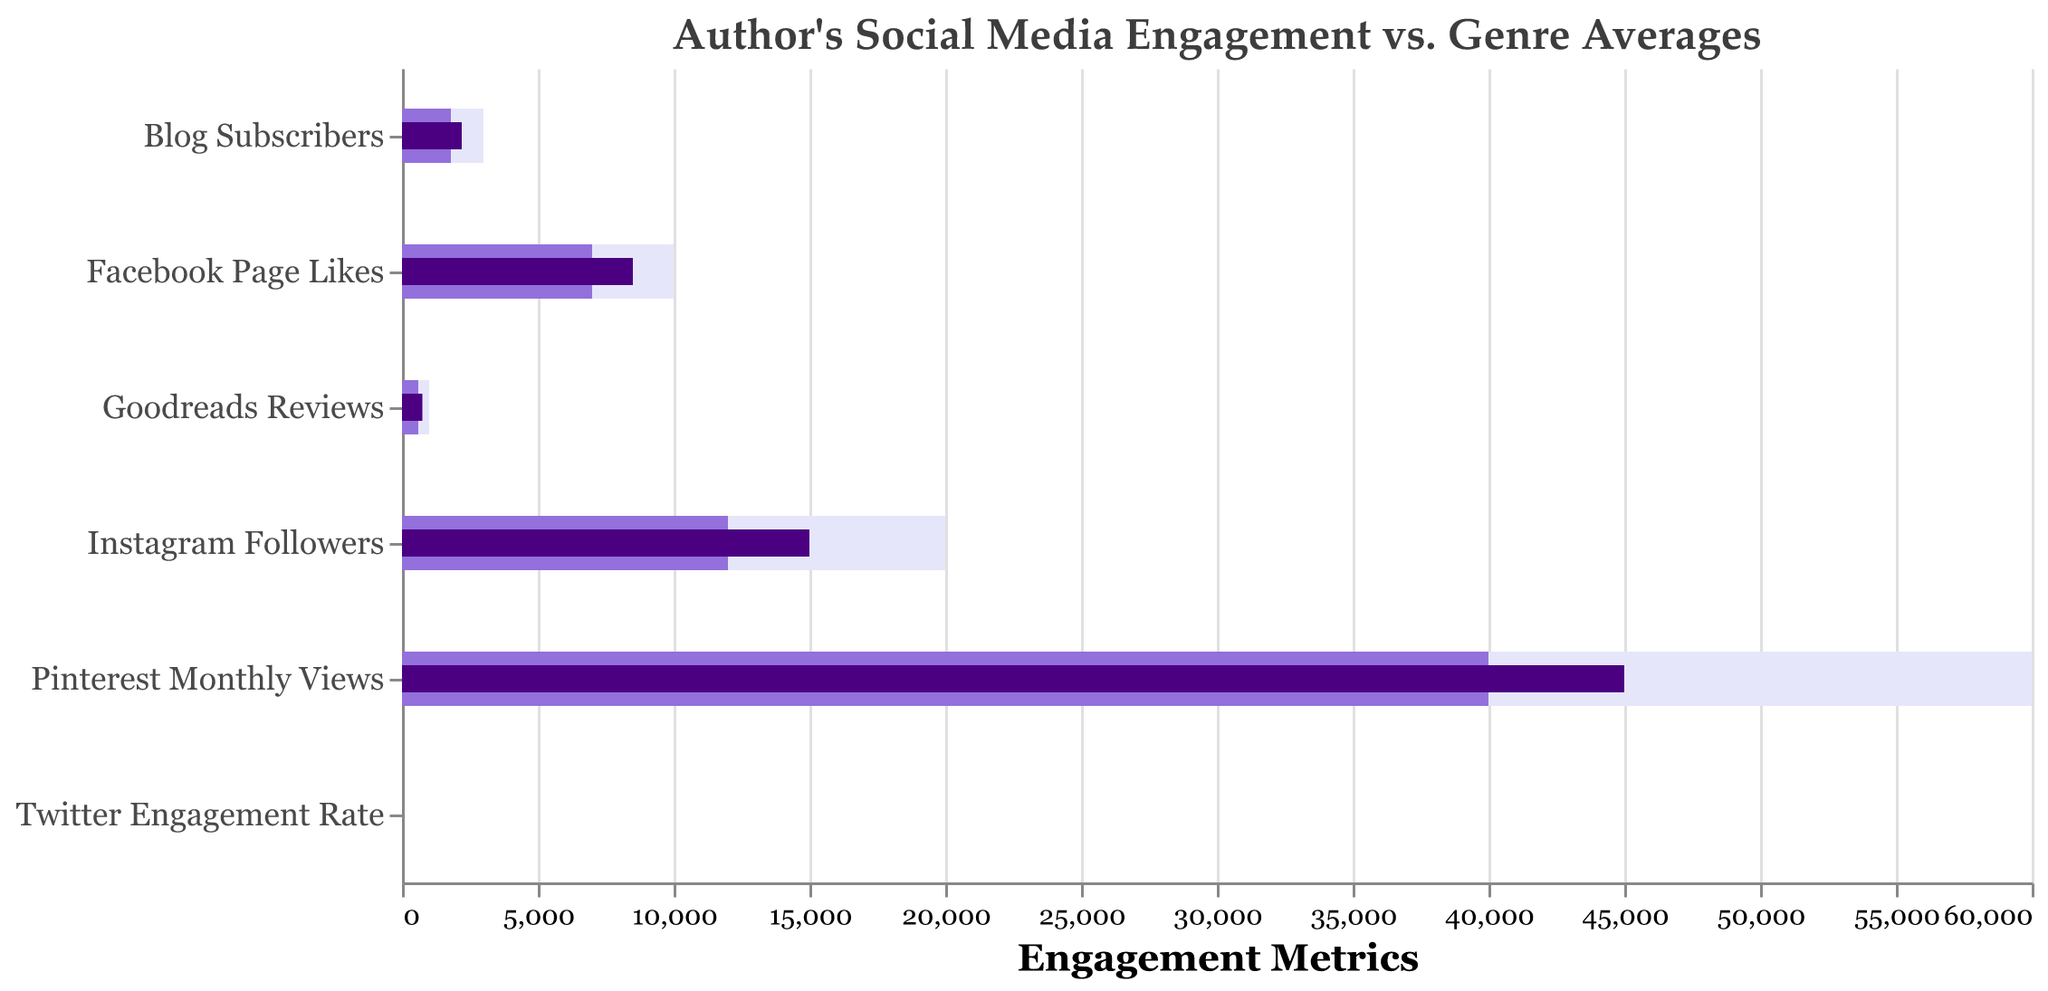What is the title of the chart? The chart's title is clearly visible at the top of the figure.
Answer: Author's Social Media Engagement vs. Genre Averages How many categories are represented in the chart? Each bar on the y-axis represents a category, and counting them gives the total number of categories.
Answer: 6 Which social media platform has the highest actual value? By comparing the actual values (darker bars) for each category, you can see that Pinterest Monthly Views has the highest actual value.
Answer: Pinterest Monthly Views What is the actual value for Goodreads Reviews? Looking at the Goodreads Reviews category and the corresponding darker shaded bar (actual value), you can identify the exact value.
Answer: 750 How does the author's actual Instagram Followers compare to the target? Compare the actual value (dark bar) to the target value (lightest bar) for Instagram Followers.
Answer: 15000 vs. 20000 (actual vs. target) Which category has the smallest difference between the actual value and the genre average? Calculate the difference between the actual (dark bar) and comparative (mid-tone bar) values for each category, and then find the smallest difference.
Answer: Twitter Engagement Rate What is the difference between the actual and target values for the Facebook Page Likes? Subtract the actual value from the target value for the Facebook Page Likes category.
Answer: 10000 - 8500 = 1500 Which category has the biggest gap between the actual value and the target value? Find the category where the difference between the actual (dark bar) and target (lightest bar) values is the largest.
Answer: Pinterest Monthly Views How do the comparative values for Instagram Followers and Blog Subscribers compare? Look at the comparative values (mid-tone bars) for both Instagram Followers and Blog Subscribers and compare them.
Answer: 12000 (Instagram Followers) vs. 1800 (Blog Subscribers) Are the author's actual Goodreads Reviews above or below the genre average? Compare the actual value (dark bar) to the comparative value (mid-tone bar) for Goodreads Reviews.
Answer: Above 